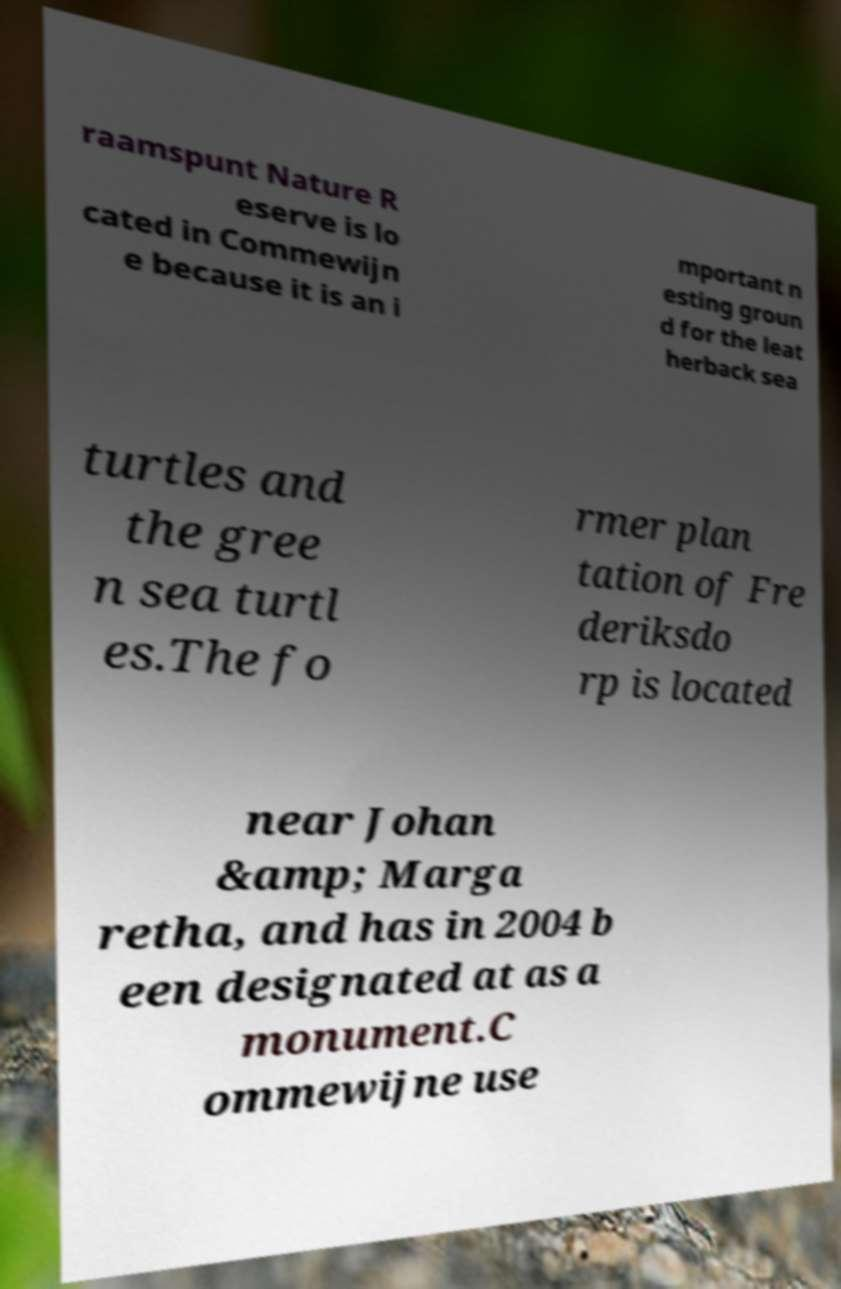Could you extract and type out the text from this image? raamspunt Nature R eserve is lo cated in Commewijn e because it is an i mportant n esting groun d for the leat herback sea turtles and the gree n sea turtl es.The fo rmer plan tation of Fre deriksdo rp is located near Johan &amp; Marga retha, and has in 2004 b een designated at as a monument.C ommewijne use 